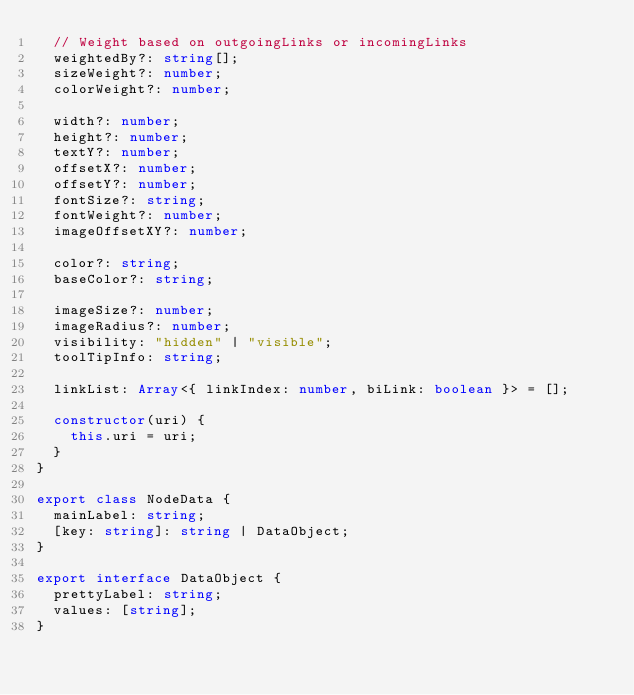<code> <loc_0><loc_0><loc_500><loc_500><_TypeScript_>  // Weight based on outgoingLinks or incomingLinks
  weightedBy?: string[];
  sizeWeight?: number;
  colorWeight?: number;

  width?: number;
  height?: number;
  textY?: number;
  offsetX?: number;
  offsetY?: number;
  fontSize?: string;
  fontWeight?: number;
  imageOffsetXY?: number;

  color?: string;
  baseColor?: string;

  imageSize?: number;
  imageRadius?: number;
  visibility: "hidden" | "visible";
  toolTipInfo: string;

  linkList: Array<{ linkIndex: number, biLink: boolean }> = [];

  constructor(uri) {
    this.uri = uri;
  }
}

export class NodeData {
  mainLabel: string;
  [key: string]: string | DataObject;
}

export interface DataObject {
  prettyLabel: string;
  values: [string];
}
</code> 